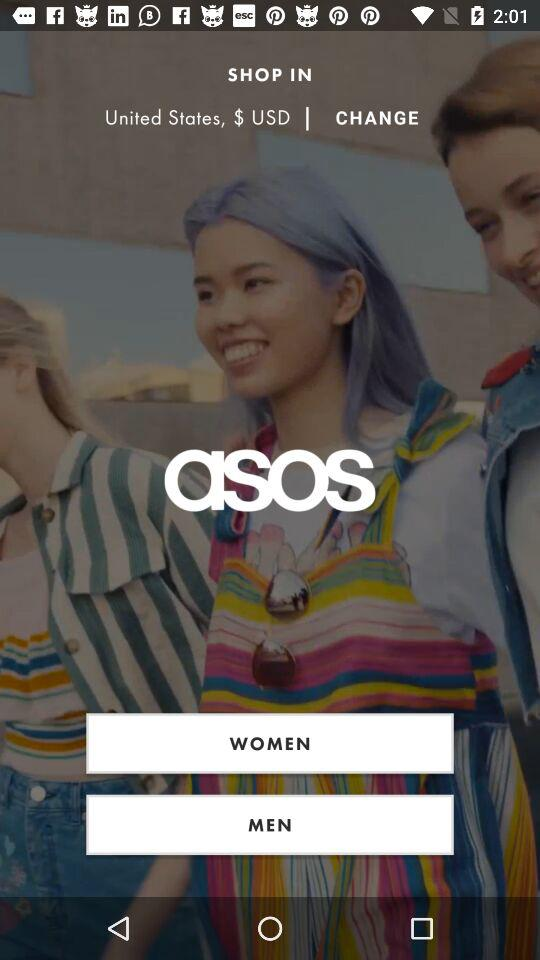What is the application name? The application name is "asos". 